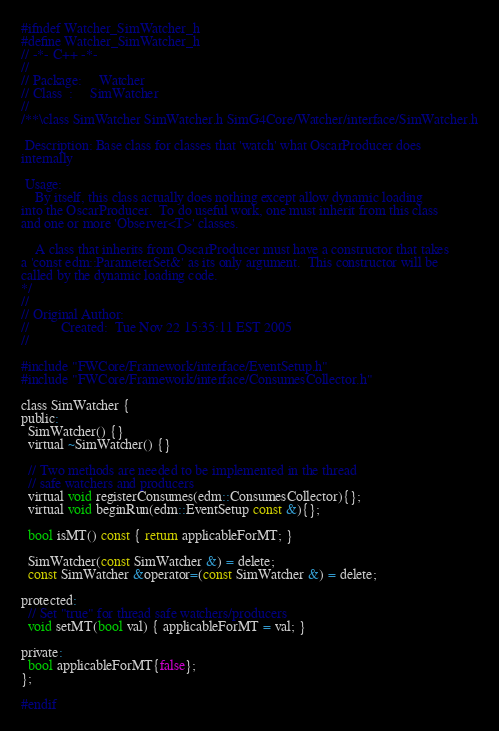<code> <loc_0><loc_0><loc_500><loc_500><_C_>#ifndef Watcher_SimWatcher_h
#define Watcher_SimWatcher_h
// -*- C++ -*-
//
// Package:     Watcher
// Class  :     SimWatcher
//
/**\class SimWatcher SimWatcher.h SimG4Core/Watcher/interface/SimWatcher.h

 Description: Base class for classes that 'watch' what OscarProducer does
internally

 Usage:
    By itself, this class actually does nothing except allow dynamic loading
into the OscarProducer.  To do useful work, one must inherit from this class
and one or more 'Observer<T>' classes.

    A class that inherits from OscarProducer must have a constructor that takes
a 'const edm::ParameterSet&' as its only argument.  This constructor will be
called by the dynamic loading code.
*/
//
// Original Author:
//         Created:  Tue Nov 22 15:35:11 EST 2005
//

#include "FWCore/Framework/interface/EventSetup.h"
#include "FWCore/Framework/interface/ConsumesCollector.h"

class SimWatcher {
public:
  SimWatcher() {}
  virtual ~SimWatcher() {}

  // Two methods are needed to be implemented in the thread
  // safe watchers and producers
  virtual void registerConsumes(edm::ConsumesCollector){};
  virtual void beginRun(edm::EventSetup const &){};

  bool isMT() const { return applicableForMT; }

  SimWatcher(const SimWatcher &) = delete;
  const SimWatcher &operator=(const SimWatcher &) = delete;

protected:
  // Set "true" for thread safe watchers/producers
  void setMT(bool val) { applicableForMT = val; }

private:
  bool applicableForMT{false};
};

#endif
</code> 